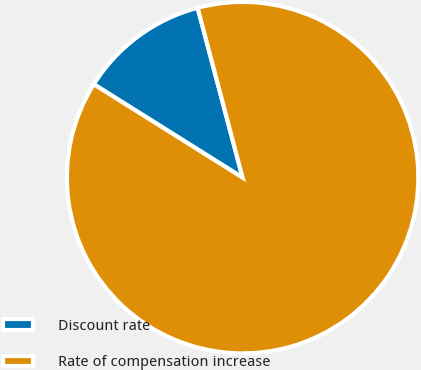Convert chart. <chart><loc_0><loc_0><loc_500><loc_500><pie_chart><fcel>Discount rate<fcel>Rate of compensation increase<nl><fcel>11.96%<fcel>88.04%<nl></chart> 